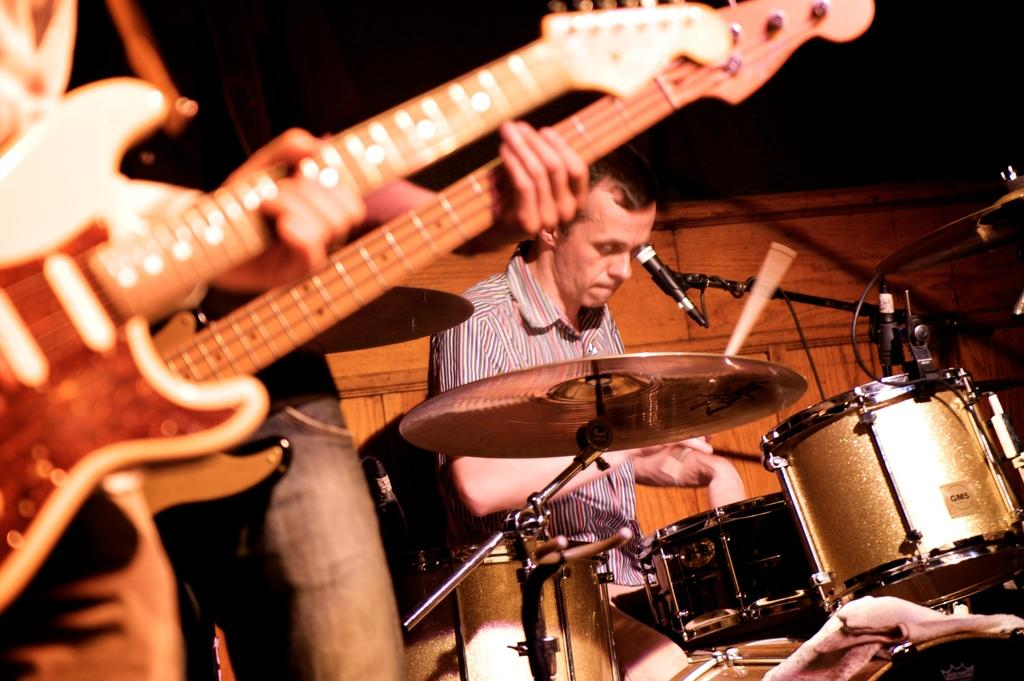Who is the main subject in the image? There is a man in the image. What is the man doing in the image? The man is sitting in the image. What is the man sitting in front of? The man is sitting in front of a mic. What other objects are present in the image? There are musical instruments in the image. What type of skin can be seen on the man's hands in the image? There is no information about the man's hands in the image, so we cannot determine the type of skin on his hands. 